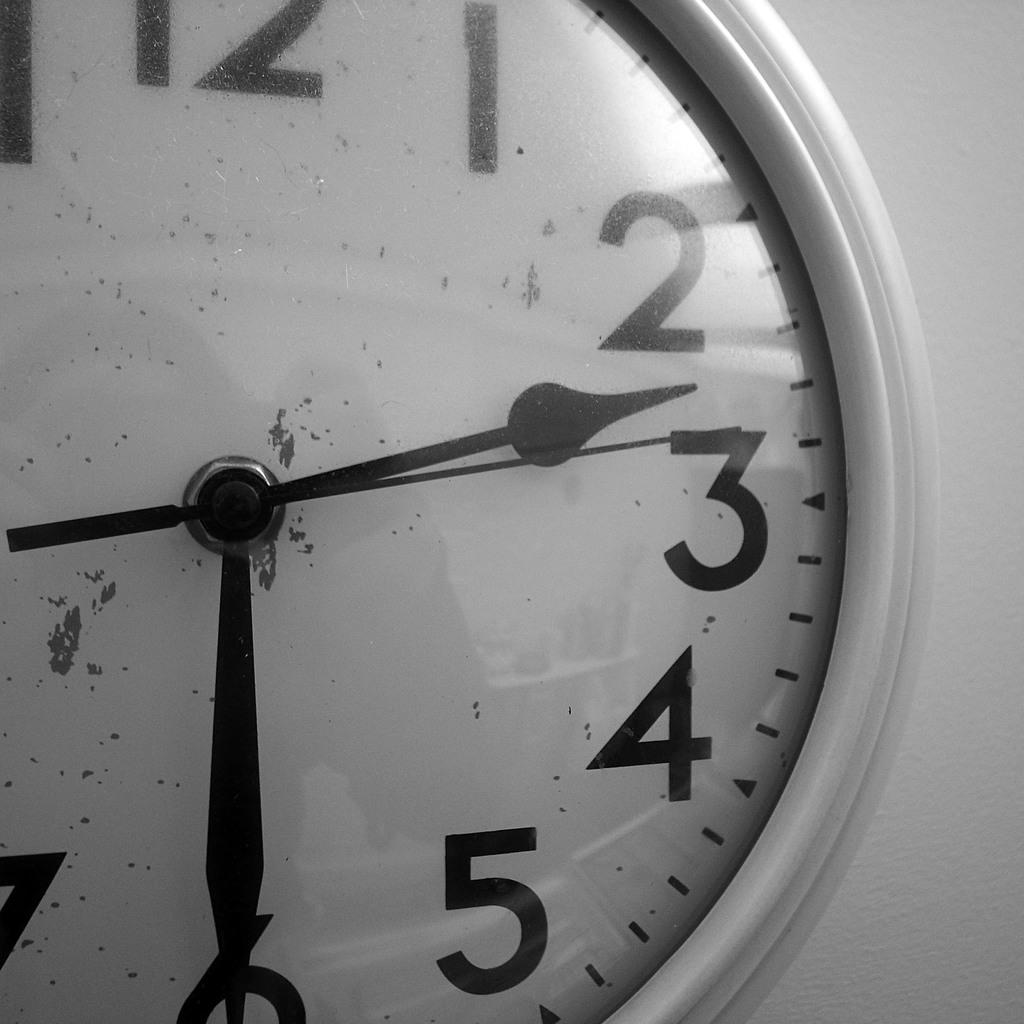<image>
Offer a succinct explanation of the picture presented. On an analog clock, the second hand is approaching the number three. 